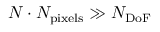Convert formula to latex. <formula><loc_0><loc_0><loc_500><loc_500>N \cdot N _ { p i x e l s } \gg N _ { D o F }</formula> 